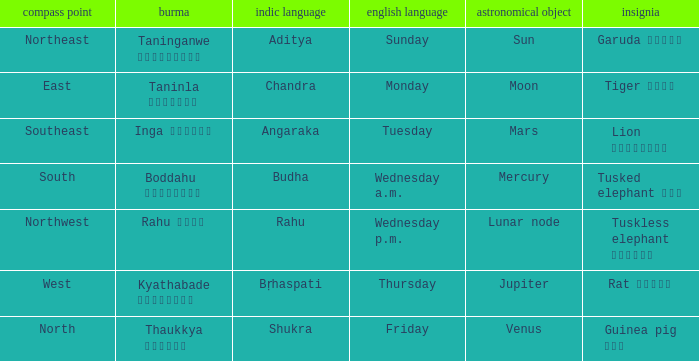What is the planet associated with the direction of south? Mercury. 